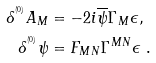Convert formula to latex. <formula><loc_0><loc_0><loc_500><loc_500>\delta ^ { ^ { ( 0 ) } } A _ { M } & = - 2 i \overline { \psi } \Gamma _ { M } \epsilon , \\ \delta ^ { ^ { ( 0 ) } } \psi & = F _ { M N } \Gamma ^ { M N } \epsilon \ .</formula> 